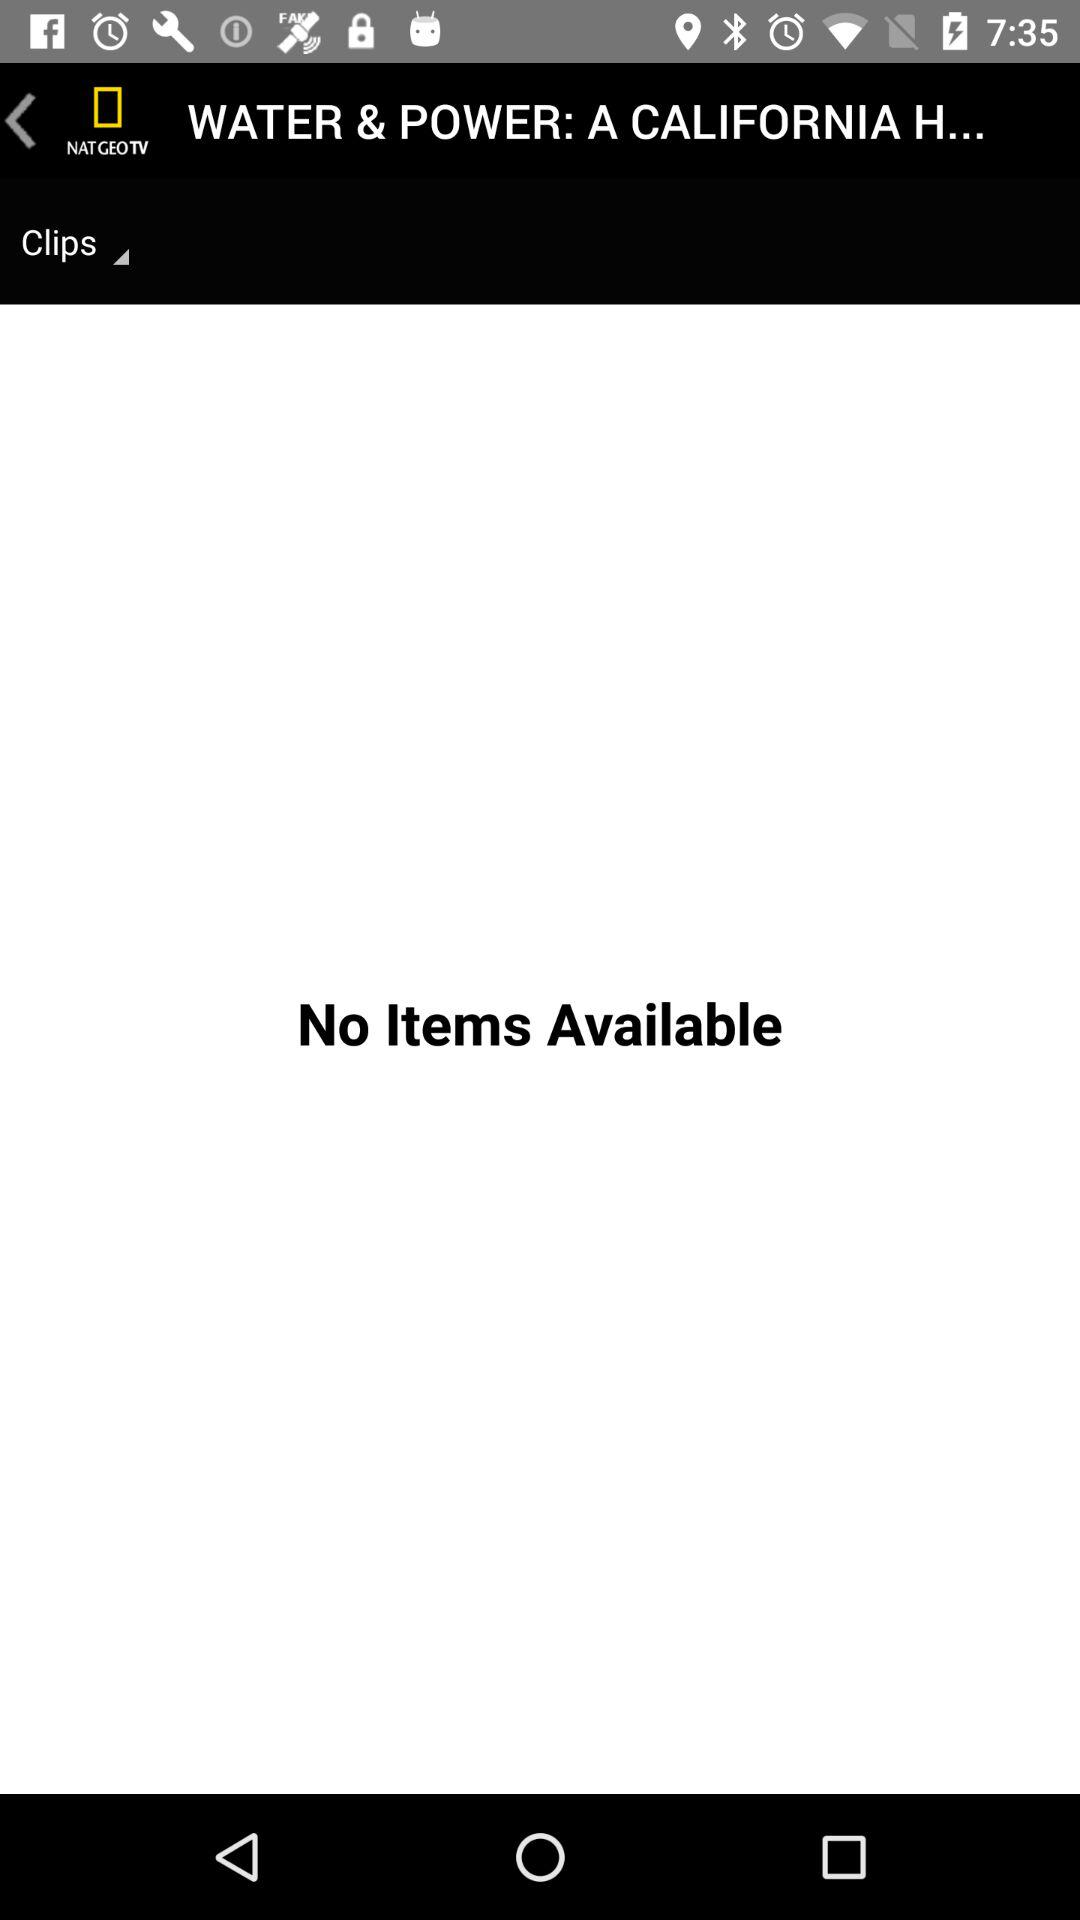Are there any items available? There are no items available. 